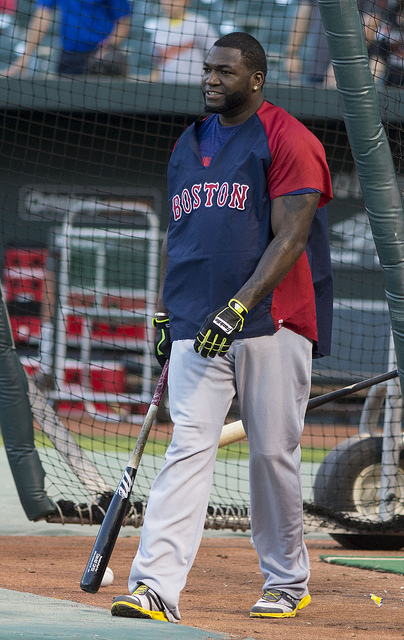<image>Which is his Jersey written? I don't know what is written on his jersey. However, it can be 'boston'. Which is his Jersey written? I don't know which is his Jersey written. It is not clear from the information given. 